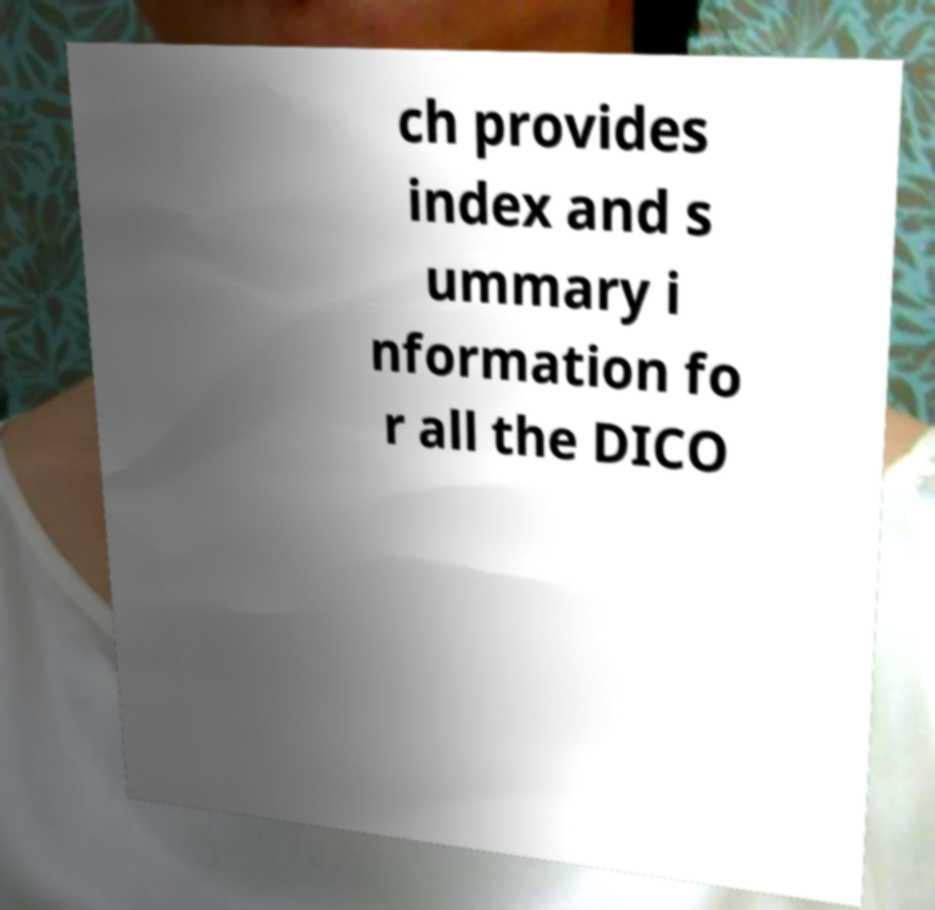For documentation purposes, I need the text within this image transcribed. Could you provide that? ch provides index and s ummary i nformation fo r all the DICO 